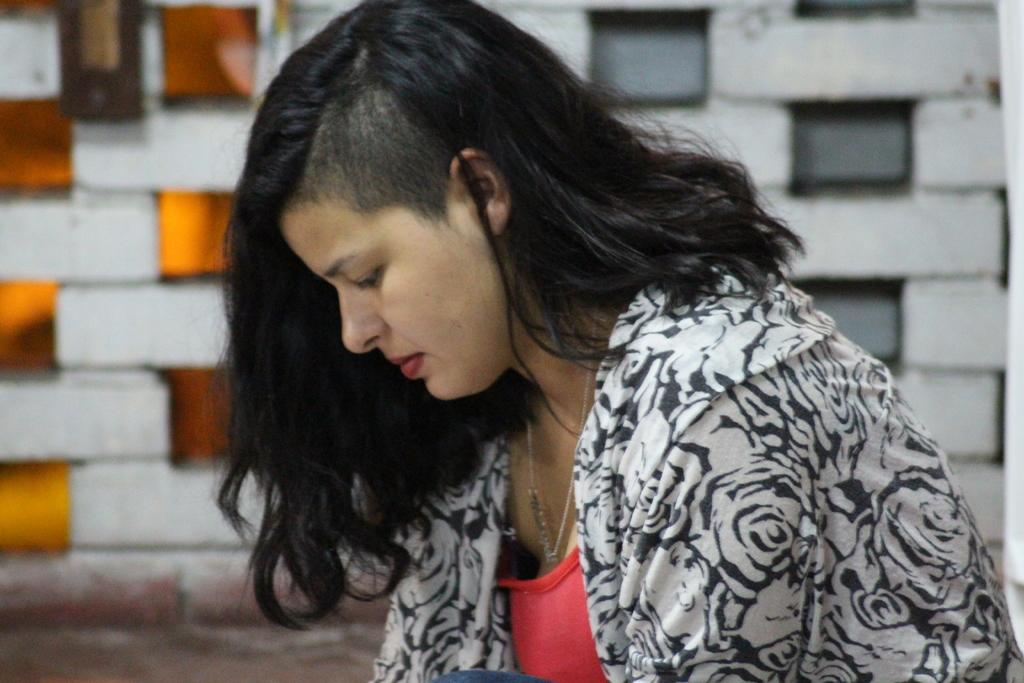Who is present in the image? There is a woman in the image. What is the woman wearing? The woman is wearing a white and black jacket. What can be seen at the bottom of the image? There is a ground visible at the bottom of the image. What type of wall can be seen in the background of the image? There is a wall made of bricks in the background of the image. What type of list can be seen in the woman's hand in the image? There is no list visible in the woman's hand in the image. What type of camera is the woman using to take pictures in the image? There is no camera present in the image, and the woman is not taking pictures. 